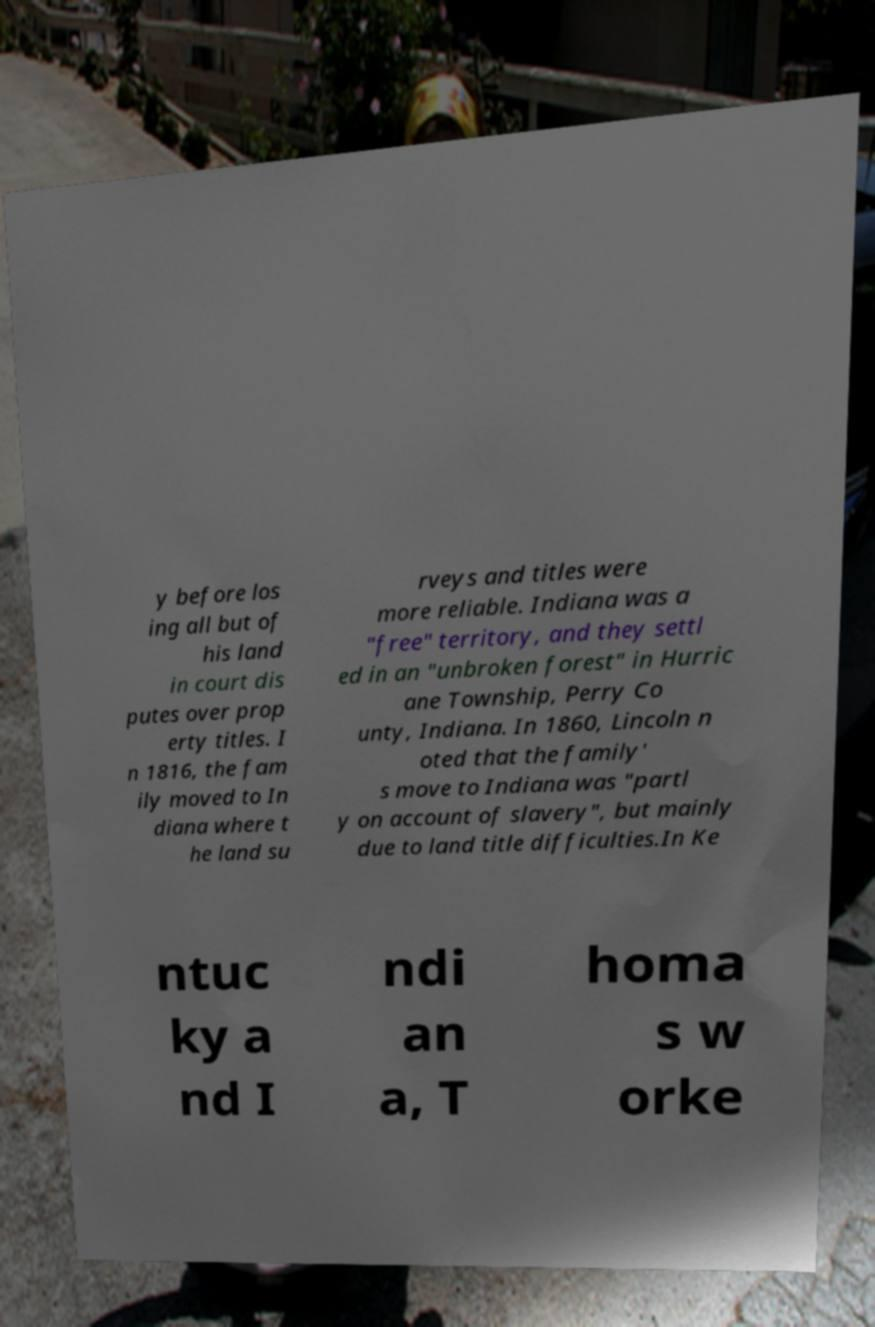Please read and relay the text visible in this image. What does it say? y before los ing all but of his land in court dis putes over prop erty titles. I n 1816, the fam ily moved to In diana where t he land su rveys and titles were more reliable. Indiana was a "free" territory, and they settl ed in an "unbroken forest" in Hurric ane Township, Perry Co unty, Indiana. In 1860, Lincoln n oted that the family' s move to Indiana was "partl y on account of slavery", but mainly due to land title difficulties.In Ke ntuc ky a nd I ndi an a, T homa s w orke 